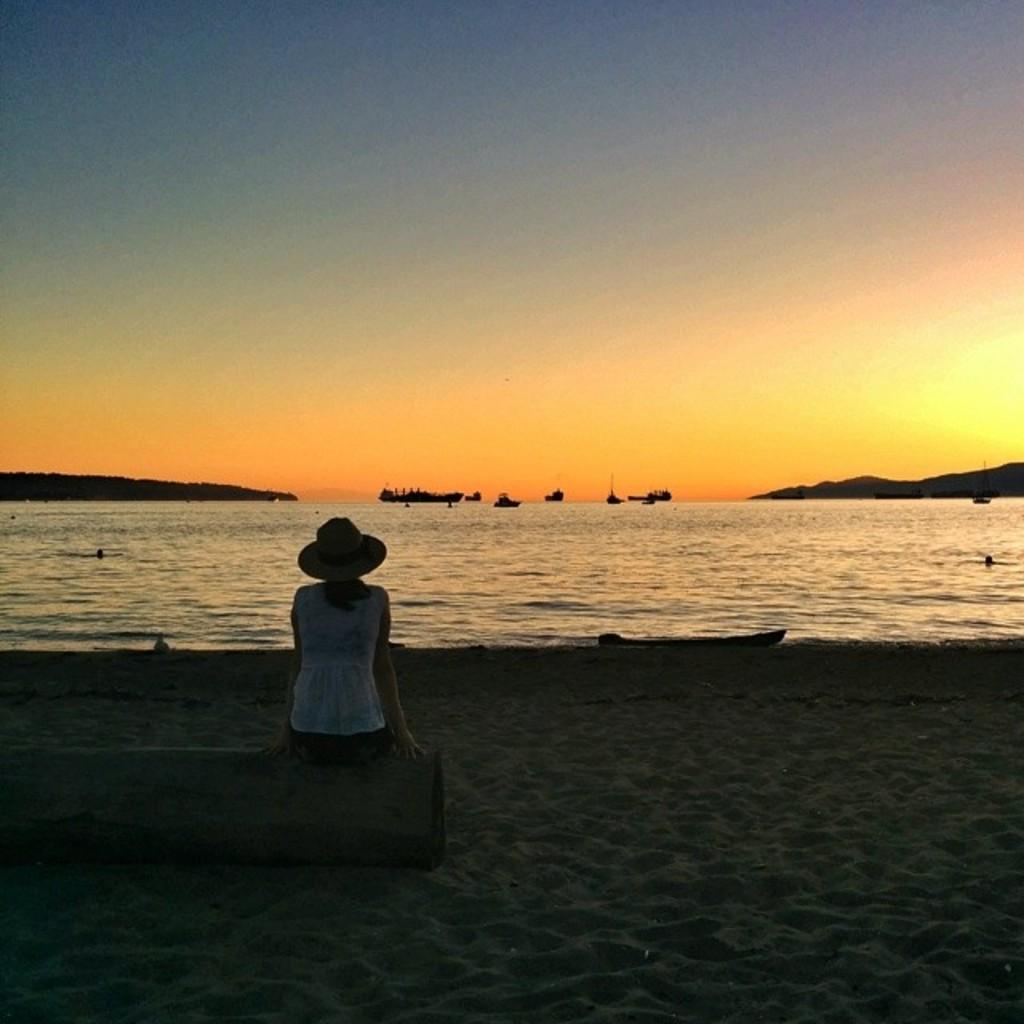Who is present in the image? There is a woman in the picture. What is the woman doing in the image? The woman is seated on a bench. What is the woman wearing on her head? The woman is wearing a cap. What can be seen in the background of the image? There is water visible in the image, and ships are in the water. What type of apparatus is the woman using to perform a trick in the image? There is no apparatus or trick being performed in the image; the woman is simply seated on a bench. What type of root can be seen growing near the woman in the image? There is no root visible in the image; the focus is on the woman seated on a bench and the water with ships in the background. 